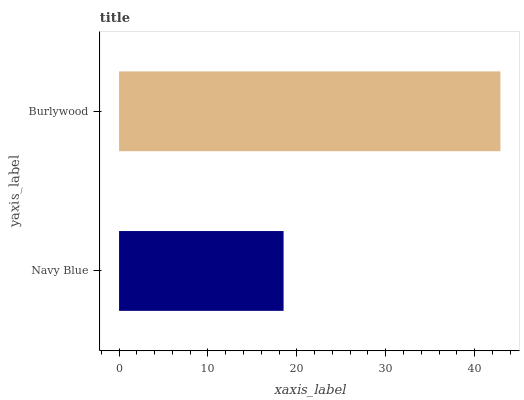Is Navy Blue the minimum?
Answer yes or no. Yes. Is Burlywood the maximum?
Answer yes or no. Yes. Is Burlywood the minimum?
Answer yes or no. No. Is Burlywood greater than Navy Blue?
Answer yes or no. Yes. Is Navy Blue less than Burlywood?
Answer yes or no. Yes. Is Navy Blue greater than Burlywood?
Answer yes or no. No. Is Burlywood less than Navy Blue?
Answer yes or no. No. Is Burlywood the high median?
Answer yes or no. Yes. Is Navy Blue the low median?
Answer yes or no. Yes. Is Navy Blue the high median?
Answer yes or no. No. Is Burlywood the low median?
Answer yes or no. No. 